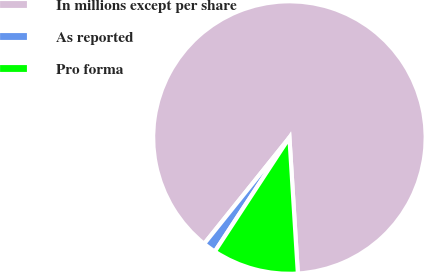<chart> <loc_0><loc_0><loc_500><loc_500><pie_chart><fcel>In millions except per share<fcel>As reported<fcel>Pro forma<nl><fcel>88.25%<fcel>1.54%<fcel>10.21%<nl></chart> 